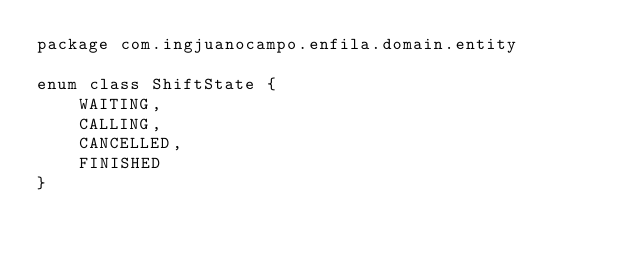<code> <loc_0><loc_0><loc_500><loc_500><_Kotlin_>package com.ingjuanocampo.enfila.domain.entity

enum class ShiftState {
    WAITING,
    CALLING,
    CANCELLED,
    FINISHED
}</code> 